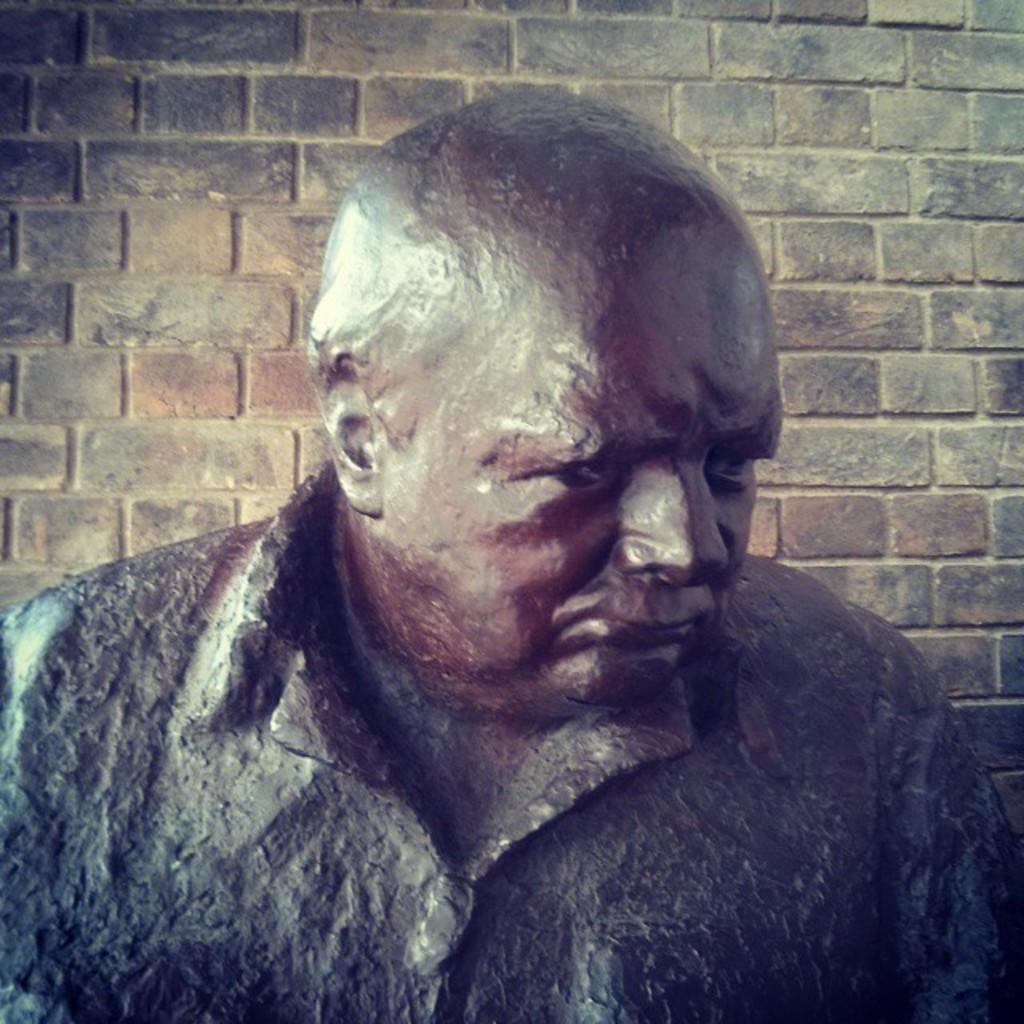What is the main subject of the image? There is a statue of a man in the image. Can you describe the appearance of the man in the statue? The man has a bald head. What can be seen in the background of the image? There is a wall visible behind the statue. What type of vest is the statue wearing in the image? The statue does not appear to be wearing a vest in the image. How does the statue support itself on the wall? The statue is a stationary object and does not need to support itself on the wall. 